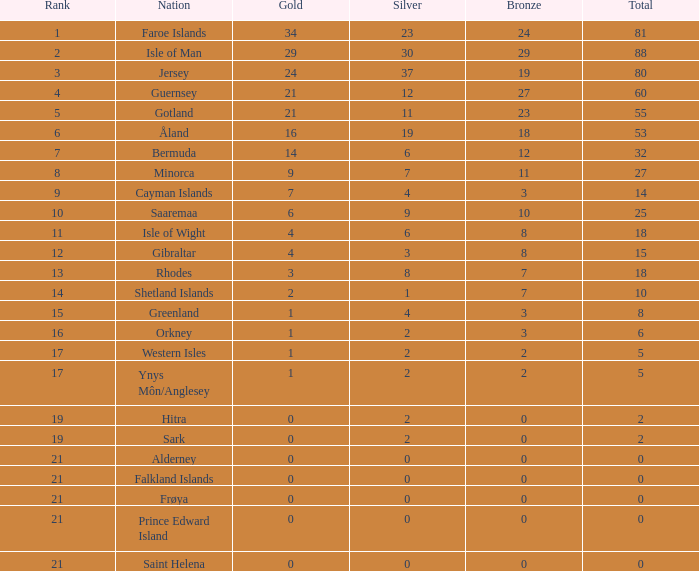What is the total number of silver medals earned by individuals who have over 3 bronze medals and precisely 16 gold medals? 19.0. 